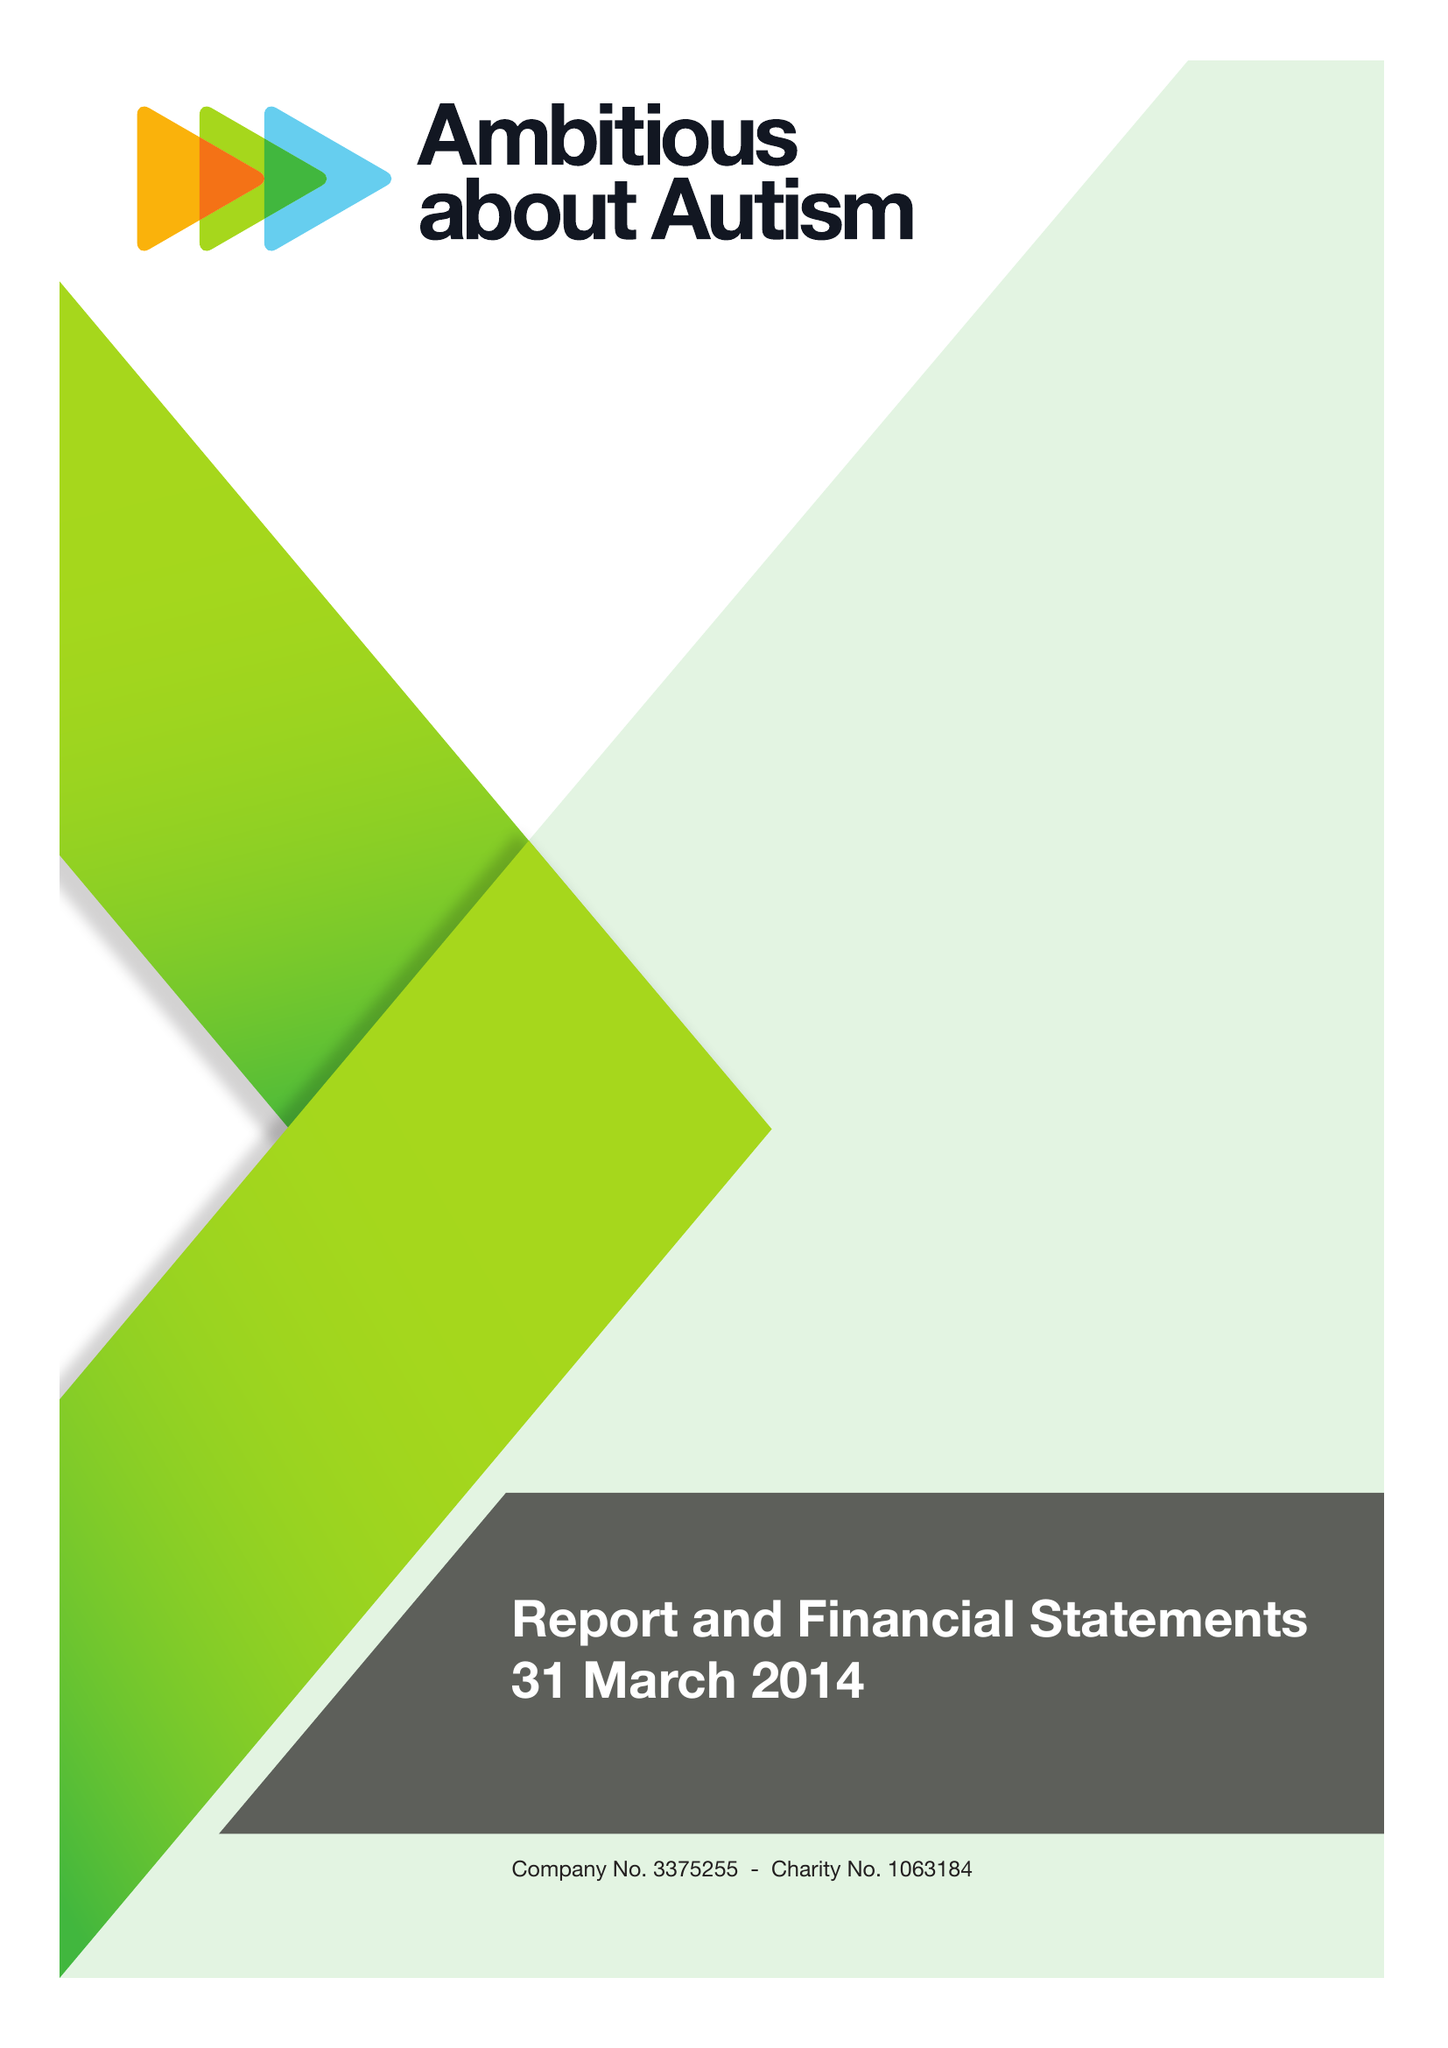What is the value for the address__postcode?
Answer the question using a single word or phrase. N10 3JA 